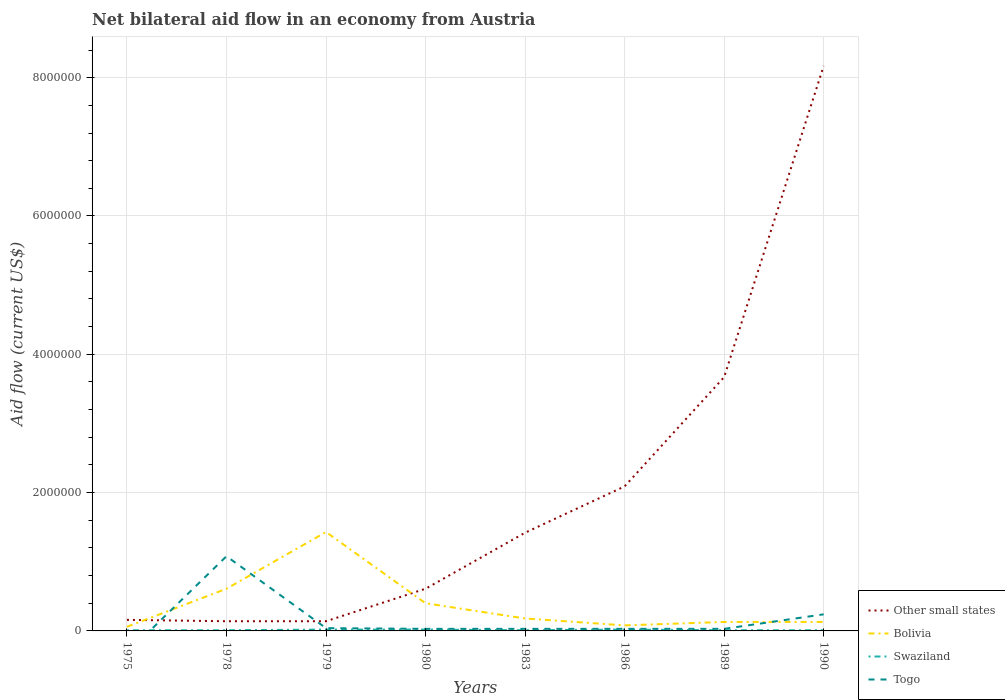How many different coloured lines are there?
Provide a short and direct response. 4. Does the line corresponding to Bolivia intersect with the line corresponding to Swaziland?
Give a very brief answer. No. Is the number of lines equal to the number of legend labels?
Keep it short and to the point. No. What is the total net bilateral aid flow in Other small states in the graph?
Make the answer very short. -8.01e+06. What is the difference between the highest and the second highest net bilateral aid flow in Other small states?
Keep it short and to the point. 8.03e+06. Is the net bilateral aid flow in Other small states strictly greater than the net bilateral aid flow in Togo over the years?
Provide a short and direct response. No. How many lines are there?
Offer a terse response. 4. How many years are there in the graph?
Your answer should be compact. 8. Are the values on the major ticks of Y-axis written in scientific E-notation?
Your answer should be very brief. No. Does the graph contain any zero values?
Make the answer very short. Yes. Does the graph contain grids?
Ensure brevity in your answer.  Yes. How many legend labels are there?
Your answer should be compact. 4. How are the legend labels stacked?
Provide a short and direct response. Vertical. What is the title of the graph?
Ensure brevity in your answer.  Net bilateral aid flow in an economy from Austria. What is the label or title of the X-axis?
Your answer should be very brief. Years. What is the Aid flow (current US$) in Bolivia in 1975?
Keep it short and to the point. 6.00e+04. What is the Aid flow (current US$) of Bolivia in 1978?
Provide a succinct answer. 6.10e+05. What is the Aid flow (current US$) of Swaziland in 1978?
Your answer should be compact. 10000. What is the Aid flow (current US$) in Togo in 1978?
Keep it short and to the point. 1.08e+06. What is the Aid flow (current US$) in Other small states in 1979?
Give a very brief answer. 1.40e+05. What is the Aid flow (current US$) in Bolivia in 1979?
Ensure brevity in your answer.  1.43e+06. What is the Aid flow (current US$) in Swaziland in 1979?
Your answer should be compact. 2.00e+04. What is the Aid flow (current US$) in Togo in 1979?
Provide a short and direct response. 4.00e+04. What is the Aid flow (current US$) in Other small states in 1980?
Make the answer very short. 6.10e+05. What is the Aid flow (current US$) of Bolivia in 1980?
Keep it short and to the point. 4.00e+05. What is the Aid flow (current US$) in Swaziland in 1980?
Your answer should be compact. 2.00e+04. What is the Aid flow (current US$) of Togo in 1980?
Offer a very short reply. 3.00e+04. What is the Aid flow (current US$) of Other small states in 1983?
Your answer should be very brief. 1.42e+06. What is the Aid flow (current US$) in Bolivia in 1983?
Offer a terse response. 1.80e+05. What is the Aid flow (current US$) in Swaziland in 1983?
Offer a terse response. 10000. What is the Aid flow (current US$) in Togo in 1983?
Your response must be concise. 3.00e+04. What is the Aid flow (current US$) in Other small states in 1986?
Give a very brief answer. 2.09e+06. What is the Aid flow (current US$) of Bolivia in 1986?
Give a very brief answer. 8.00e+04. What is the Aid flow (current US$) of Other small states in 1989?
Your answer should be very brief. 3.67e+06. What is the Aid flow (current US$) of Other small states in 1990?
Offer a very short reply. 8.17e+06. What is the Aid flow (current US$) of Togo in 1990?
Your answer should be compact. 2.40e+05. Across all years, what is the maximum Aid flow (current US$) of Other small states?
Offer a very short reply. 8.17e+06. Across all years, what is the maximum Aid flow (current US$) of Bolivia?
Offer a very short reply. 1.43e+06. Across all years, what is the maximum Aid flow (current US$) in Swaziland?
Give a very brief answer. 2.00e+04. Across all years, what is the maximum Aid flow (current US$) in Togo?
Offer a very short reply. 1.08e+06. Across all years, what is the minimum Aid flow (current US$) in Other small states?
Offer a very short reply. 1.40e+05. Across all years, what is the minimum Aid flow (current US$) of Bolivia?
Make the answer very short. 6.00e+04. Across all years, what is the minimum Aid flow (current US$) of Swaziland?
Your answer should be compact. 10000. Across all years, what is the minimum Aid flow (current US$) of Togo?
Provide a succinct answer. 0. What is the total Aid flow (current US$) of Other small states in the graph?
Ensure brevity in your answer.  1.64e+07. What is the total Aid flow (current US$) in Bolivia in the graph?
Your response must be concise. 3.02e+06. What is the total Aid flow (current US$) of Togo in the graph?
Offer a terse response. 1.48e+06. What is the difference between the Aid flow (current US$) of Bolivia in 1975 and that in 1978?
Your response must be concise. -5.50e+05. What is the difference between the Aid flow (current US$) in Bolivia in 1975 and that in 1979?
Give a very brief answer. -1.37e+06. What is the difference between the Aid flow (current US$) of Other small states in 1975 and that in 1980?
Offer a very short reply. -4.50e+05. What is the difference between the Aid flow (current US$) of Bolivia in 1975 and that in 1980?
Give a very brief answer. -3.40e+05. What is the difference between the Aid flow (current US$) of Swaziland in 1975 and that in 1980?
Your response must be concise. -10000. What is the difference between the Aid flow (current US$) of Other small states in 1975 and that in 1983?
Offer a very short reply. -1.26e+06. What is the difference between the Aid flow (current US$) of Other small states in 1975 and that in 1986?
Offer a terse response. -1.93e+06. What is the difference between the Aid flow (current US$) of Bolivia in 1975 and that in 1986?
Provide a short and direct response. -2.00e+04. What is the difference between the Aid flow (current US$) of Swaziland in 1975 and that in 1986?
Keep it short and to the point. -10000. What is the difference between the Aid flow (current US$) of Other small states in 1975 and that in 1989?
Make the answer very short. -3.51e+06. What is the difference between the Aid flow (current US$) of Bolivia in 1975 and that in 1989?
Your answer should be compact. -7.00e+04. What is the difference between the Aid flow (current US$) of Swaziland in 1975 and that in 1989?
Give a very brief answer. 0. What is the difference between the Aid flow (current US$) of Other small states in 1975 and that in 1990?
Make the answer very short. -8.01e+06. What is the difference between the Aid flow (current US$) in Bolivia in 1975 and that in 1990?
Provide a short and direct response. -7.00e+04. What is the difference between the Aid flow (current US$) in Other small states in 1978 and that in 1979?
Your answer should be compact. 0. What is the difference between the Aid flow (current US$) in Bolivia in 1978 and that in 1979?
Your answer should be very brief. -8.20e+05. What is the difference between the Aid flow (current US$) of Togo in 1978 and that in 1979?
Offer a very short reply. 1.04e+06. What is the difference between the Aid flow (current US$) in Other small states in 1978 and that in 1980?
Provide a succinct answer. -4.70e+05. What is the difference between the Aid flow (current US$) in Togo in 1978 and that in 1980?
Offer a terse response. 1.05e+06. What is the difference between the Aid flow (current US$) of Other small states in 1978 and that in 1983?
Provide a succinct answer. -1.28e+06. What is the difference between the Aid flow (current US$) of Togo in 1978 and that in 1983?
Keep it short and to the point. 1.05e+06. What is the difference between the Aid flow (current US$) of Other small states in 1978 and that in 1986?
Your answer should be compact. -1.95e+06. What is the difference between the Aid flow (current US$) in Bolivia in 1978 and that in 1986?
Provide a succinct answer. 5.30e+05. What is the difference between the Aid flow (current US$) of Swaziland in 1978 and that in 1986?
Offer a terse response. -10000. What is the difference between the Aid flow (current US$) of Togo in 1978 and that in 1986?
Give a very brief answer. 1.05e+06. What is the difference between the Aid flow (current US$) of Other small states in 1978 and that in 1989?
Give a very brief answer. -3.53e+06. What is the difference between the Aid flow (current US$) in Bolivia in 1978 and that in 1989?
Provide a short and direct response. 4.80e+05. What is the difference between the Aid flow (current US$) in Togo in 1978 and that in 1989?
Give a very brief answer. 1.05e+06. What is the difference between the Aid flow (current US$) of Other small states in 1978 and that in 1990?
Offer a terse response. -8.03e+06. What is the difference between the Aid flow (current US$) of Togo in 1978 and that in 1990?
Offer a very short reply. 8.40e+05. What is the difference between the Aid flow (current US$) of Other small states in 1979 and that in 1980?
Ensure brevity in your answer.  -4.70e+05. What is the difference between the Aid flow (current US$) in Bolivia in 1979 and that in 1980?
Your answer should be very brief. 1.03e+06. What is the difference between the Aid flow (current US$) of Swaziland in 1979 and that in 1980?
Give a very brief answer. 0. What is the difference between the Aid flow (current US$) of Togo in 1979 and that in 1980?
Ensure brevity in your answer.  10000. What is the difference between the Aid flow (current US$) in Other small states in 1979 and that in 1983?
Your response must be concise. -1.28e+06. What is the difference between the Aid flow (current US$) of Bolivia in 1979 and that in 1983?
Give a very brief answer. 1.25e+06. What is the difference between the Aid flow (current US$) of Togo in 1979 and that in 1983?
Your answer should be compact. 10000. What is the difference between the Aid flow (current US$) in Other small states in 1979 and that in 1986?
Offer a very short reply. -1.95e+06. What is the difference between the Aid flow (current US$) in Bolivia in 1979 and that in 1986?
Provide a succinct answer. 1.35e+06. What is the difference between the Aid flow (current US$) in Other small states in 1979 and that in 1989?
Your answer should be very brief. -3.53e+06. What is the difference between the Aid flow (current US$) in Bolivia in 1979 and that in 1989?
Make the answer very short. 1.30e+06. What is the difference between the Aid flow (current US$) of Swaziland in 1979 and that in 1989?
Ensure brevity in your answer.  10000. What is the difference between the Aid flow (current US$) in Togo in 1979 and that in 1989?
Make the answer very short. 10000. What is the difference between the Aid flow (current US$) of Other small states in 1979 and that in 1990?
Give a very brief answer. -8.03e+06. What is the difference between the Aid flow (current US$) of Bolivia in 1979 and that in 1990?
Give a very brief answer. 1.30e+06. What is the difference between the Aid flow (current US$) in Other small states in 1980 and that in 1983?
Your answer should be compact. -8.10e+05. What is the difference between the Aid flow (current US$) of Togo in 1980 and that in 1983?
Ensure brevity in your answer.  0. What is the difference between the Aid flow (current US$) in Other small states in 1980 and that in 1986?
Provide a succinct answer. -1.48e+06. What is the difference between the Aid flow (current US$) in Bolivia in 1980 and that in 1986?
Provide a short and direct response. 3.20e+05. What is the difference between the Aid flow (current US$) in Togo in 1980 and that in 1986?
Make the answer very short. 0. What is the difference between the Aid flow (current US$) of Other small states in 1980 and that in 1989?
Make the answer very short. -3.06e+06. What is the difference between the Aid flow (current US$) in Bolivia in 1980 and that in 1989?
Provide a short and direct response. 2.70e+05. What is the difference between the Aid flow (current US$) of Togo in 1980 and that in 1989?
Keep it short and to the point. 0. What is the difference between the Aid flow (current US$) in Other small states in 1980 and that in 1990?
Provide a succinct answer. -7.56e+06. What is the difference between the Aid flow (current US$) of Bolivia in 1980 and that in 1990?
Offer a very short reply. 2.70e+05. What is the difference between the Aid flow (current US$) of Swaziland in 1980 and that in 1990?
Keep it short and to the point. 10000. What is the difference between the Aid flow (current US$) in Togo in 1980 and that in 1990?
Offer a terse response. -2.10e+05. What is the difference between the Aid flow (current US$) of Other small states in 1983 and that in 1986?
Give a very brief answer. -6.70e+05. What is the difference between the Aid flow (current US$) of Bolivia in 1983 and that in 1986?
Provide a succinct answer. 1.00e+05. What is the difference between the Aid flow (current US$) of Swaziland in 1983 and that in 1986?
Offer a terse response. -10000. What is the difference between the Aid flow (current US$) of Togo in 1983 and that in 1986?
Your answer should be compact. 0. What is the difference between the Aid flow (current US$) of Other small states in 1983 and that in 1989?
Ensure brevity in your answer.  -2.25e+06. What is the difference between the Aid flow (current US$) in Bolivia in 1983 and that in 1989?
Ensure brevity in your answer.  5.00e+04. What is the difference between the Aid flow (current US$) of Swaziland in 1983 and that in 1989?
Offer a terse response. 0. What is the difference between the Aid flow (current US$) in Other small states in 1983 and that in 1990?
Keep it short and to the point. -6.75e+06. What is the difference between the Aid flow (current US$) in Bolivia in 1983 and that in 1990?
Provide a short and direct response. 5.00e+04. What is the difference between the Aid flow (current US$) of Swaziland in 1983 and that in 1990?
Provide a succinct answer. 0. What is the difference between the Aid flow (current US$) in Togo in 1983 and that in 1990?
Make the answer very short. -2.10e+05. What is the difference between the Aid flow (current US$) in Other small states in 1986 and that in 1989?
Provide a succinct answer. -1.58e+06. What is the difference between the Aid flow (current US$) of Other small states in 1986 and that in 1990?
Provide a succinct answer. -6.08e+06. What is the difference between the Aid flow (current US$) of Other small states in 1989 and that in 1990?
Offer a terse response. -4.50e+06. What is the difference between the Aid flow (current US$) in Bolivia in 1989 and that in 1990?
Provide a succinct answer. 0. What is the difference between the Aid flow (current US$) of Other small states in 1975 and the Aid flow (current US$) of Bolivia in 1978?
Keep it short and to the point. -4.50e+05. What is the difference between the Aid flow (current US$) of Other small states in 1975 and the Aid flow (current US$) of Swaziland in 1978?
Your answer should be compact. 1.50e+05. What is the difference between the Aid flow (current US$) of Other small states in 1975 and the Aid flow (current US$) of Togo in 1978?
Your answer should be very brief. -9.20e+05. What is the difference between the Aid flow (current US$) in Bolivia in 1975 and the Aid flow (current US$) in Togo in 1978?
Your response must be concise. -1.02e+06. What is the difference between the Aid flow (current US$) of Swaziland in 1975 and the Aid flow (current US$) of Togo in 1978?
Offer a terse response. -1.07e+06. What is the difference between the Aid flow (current US$) in Other small states in 1975 and the Aid flow (current US$) in Bolivia in 1979?
Provide a short and direct response. -1.27e+06. What is the difference between the Aid flow (current US$) of Bolivia in 1975 and the Aid flow (current US$) of Swaziland in 1979?
Give a very brief answer. 4.00e+04. What is the difference between the Aid flow (current US$) of Other small states in 1975 and the Aid flow (current US$) of Swaziland in 1980?
Make the answer very short. 1.40e+05. What is the difference between the Aid flow (current US$) of Other small states in 1975 and the Aid flow (current US$) of Togo in 1980?
Your answer should be very brief. 1.30e+05. What is the difference between the Aid flow (current US$) in Bolivia in 1975 and the Aid flow (current US$) in Swaziland in 1980?
Offer a terse response. 4.00e+04. What is the difference between the Aid flow (current US$) of Other small states in 1975 and the Aid flow (current US$) of Swaziland in 1983?
Provide a succinct answer. 1.50e+05. What is the difference between the Aid flow (current US$) in Other small states in 1975 and the Aid flow (current US$) in Togo in 1983?
Offer a very short reply. 1.30e+05. What is the difference between the Aid flow (current US$) in Bolivia in 1975 and the Aid flow (current US$) in Swaziland in 1983?
Ensure brevity in your answer.  5.00e+04. What is the difference between the Aid flow (current US$) in Bolivia in 1975 and the Aid flow (current US$) in Togo in 1983?
Give a very brief answer. 3.00e+04. What is the difference between the Aid flow (current US$) in Other small states in 1975 and the Aid flow (current US$) in Bolivia in 1986?
Offer a terse response. 8.00e+04. What is the difference between the Aid flow (current US$) in Bolivia in 1975 and the Aid flow (current US$) in Swaziland in 1986?
Give a very brief answer. 4.00e+04. What is the difference between the Aid flow (current US$) in Swaziland in 1975 and the Aid flow (current US$) in Togo in 1986?
Offer a very short reply. -2.00e+04. What is the difference between the Aid flow (current US$) of Other small states in 1975 and the Aid flow (current US$) of Swaziland in 1989?
Provide a succinct answer. 1.50e+05. What is the difference between the Aid flow (current US$) of Other small states in 1975 and the Aid flow (current US$) of Togo in 1989?
Provide a succinct answer. 1.30e+05. What is the difference between the Aid flow (current US$) of Bolivia in 1975 and the Aid flow (current US$) of Swaziland in 1989?
Provide a succinct answer. 5.00e+04. What is the difference between the Aid flow (current US$) in Bolivia in 1975 and the Aid flow (current US$) in Togo in 1989?
Your answer should be very brief. 3.00e+04. What is the difference between the Aid flow (current US$) in Other small states in 1975 and the Aid flow (current US$) in Togo in 1990?
Provide a succinct answer. -8.00e+04. What is the difference between the Aid flow (current US$) of Bolivia in 1975 and the Aid flow (current US$) of Swaziland in 1990?
Provide a short and direct response. 5.00e+04. What is the difference between the Aid flow (current US$) in Bolivia in 1975 and the Aid flow (current US$) in Togo in 1990?
Provide a short and direct response. -1.80e+05. What is the difference between the Aid flow (current US$) of Other small states in 1978 and the Aid flow (current US$) of Bolivia in 1979?
Keep it short and to the point. -1.29e+06. What is the difference between the Aid flow (current US$) in Other small states in 1978 and the Aid flow (current US$) in Swaziland in 1979?
Your answer should be compact. 1.20e+05. What is the difference between the Aid flow (current US$) of Bolivia in 1978 and the Aid flow (current US$) of Swaziland in 1979?
Your answer should be compact. 5.90e+05. What is the difference between the Aid flow (current US$) of Bolivia in 1978 and the Aid flow (current US$) of Togo in 1979?
Offer a very short reply. 5.70e+05. What is the difference between the Aid flow (current US$) of Swaziland in 1978 and the Aid flow (current US$) of Togo in 1979?
Give a very brief answer. -3.00e+04. What is the difference between the Aid flow (current US$) in Other small states in 1978 and the Aid flow (current US$) in Bolivia in 1980?
Offer a very short reply. -2.60e+05. What is the difference between the Aid flow (current US$) of Other small states in 1978 and the Aid flow (current US$) of Swaziland in 1980?
Give a very brief answer. 1.20e+05. What is the difference between the Aid flow (current US$) in Other small states in 1978 and the Aid flow (current US$) in Togo in 1980?
Provide a succinct answer. 1.10e+05. What is the difference between the Aid flow (current US$) in Bolivia in 1978 and the Aid flow (current US$) in Swaziland in 1980?
Your answer should be very brief. 5.90e+05. What is the difference between the Aid flow (current US$) in Bolivia in 1978 and the Aid flow (current US$) in Togo in 1980?
Ensure brevity in your answer.  5.80e+05. What is the difference between the Aid flow (current US$) of Swaziland in 1978 and the Aid flow (current US$) of Togo in 1980?
Offer a terse response. -2.00e+04. What is the difference between the Aid flow (current US$) in Other small states in 1978 and the Aid flow (current US$) in Swaziland in 1983?
Your answer should be compact. 1.30e+05. What is the difference between the Aid flow (current US$) of Bolivia in 1978 and the Aid flow (current US$) of Swaziland in 1983?
Make the answer very short. 6.00e+05. What is the difference between the Aid flow (current US$) of Bolivia in 1978 and the Aid flow (current US$) of Togo in 1983?
Give a very brief answer. 5.80e+05. What is the difference between the Aid flow (current US$) of Swaziland in 1978 and the Aid flow (current US$) of Togo in 1983?
Your response must be concise. -2.00e+04. What is the difference between the Aid flow (current US$) in Bolivia in 1978 and the Aid flow (current US$) in Swaziland in 1986?
Offer a very short reply. 5.90e+05. What is the difference between the Aid flow (current US$) of Bolivia in 1978 and the Aid flow (current US$) of Togo in 1986?
Give a very brief answer. 5.80e+05. What is the difference between the Aid flow (current US$) of Swaziland in 1978 and the Aid flow (current US$) of Togo in 1986?
Provide a short and direct response. -2.00e+04. What is the difference between the Aid flow (current US$) in Other small states in 1978 and the Aid flow (current US$) in Togo in 1989?
Your answer should be compact. 1.10e+05. What is the difference between the Aid flow (current US$) in Bolivia in 1978 and the Aid flow (current US$) in Swaziland in 1989?
Offer a terse response. 6.00e+05. What is the difference between the Aid flow (current US$) in Bolivia in 1978 and the Aid flow (current US$) in Togo in 1989?
Offer a very short reply. 5.80e+05. What is the difference between the Aid flow (current US$) in Swaziland in 1978 and the Aid flow (current US$) in Togo in 1989?
Give a very brief answer. -2.00e+04. What is the difference between the Aid flow (current US$) of Other small states in 1978 and the Aid flow (current US$) of Bolivia in 1990?
Offer a very short reply. 10000. What is the difference between the Aid flow (current US$) in Other small states in 1979 and the Aid flow (current US$) in Bolivia in 1980?
Your answer should be compact. -2.60e+05. What is the difference between the Aid flow (current US$) of Other small states in 1979 and the Aid flow (current US$) of Swaziland in 1980?
Your answer should be very brief. 1.20e+05. What is the difference between the Aid flow (current US$) of Other small states in 1979 and the Aid flow (current US$) of Togo in 1980?
Offer a very short reply. 1.10e+05. What is the difference between the Aid flow (current US$) of Bolivia in 1979 and the Aid flow (current US$) of Swaziland in 1980?
Provide a succinct answer. 1.41e+06. What is the difference between the Aid flow (current US$) in Bolivia in 1979 and the Aid flow (current US$) in Togo in 1980?
Give a very brief answer. 1.40e+06. What is the difference between the Aid flow (current US$) of Other small states in 1979 and the Aid flow (current US$) of Bolivia in 1983?
Provide a succinct answer. -4.00e+04. What is the difference between the Aid flow (current US$) of Bolivia in 1979 and the Aid flow (current US$) of Swaziland in 1983?
Offer a very short reply. 1.42e+06. What is the difference between the Aid flow (current US$) of Bolivia in 1979 and the Aid flow (current US$) of Togo in 1983?
Offer a very short reply. 1.40e+06. What is the difference between the Aid flow (current US$) in Swaziland in 1979 and the Aid flow (current US$) in Togo in 1983?
Provide a succinct answer. -10000. What is the difference between the Aid flow (current US$) of Other small states in 1979 and the Aid flow (current US$) of Swaziland in 1986?
Offer a very short reply. 1.20e+05. What is the difference between the Aid flow (current US$) in Bolivia in 1979 and the Aid flow (current US$) in Swaziland in 1986?
Offer a very short reply. 1.41e+06. What is the difference between the Aid flow (current US$) in Bolivia in 1979 and the Aid flow (current US$) in Togo in 1986?
Ensure brevity in your answer.  1.40e+06. What is the difference between the Aid flow (current US$) of Swaziland in 1979 and the Aid flow (current US$) of Togo in 1986?
Keep it short and to the point. -10000. What is the difference between the Aid flow (current US$) in Other small states in 1979 and the Aid flow (current US$) in Bolivia in 1989?
Make the answer very short. 10000. What is the difference between the Aid flow (current US$) of Other small states in 1979 and the Aid flow (current US$) of Swaziland in 1989?
Your response must be concise. 1.30e+05. What is the difference between the Aid flow (current US$) of Other small states in 1979 and the Aid flow (current US$) of Togo in 1989?
Make the answer very short. 1.10e+05. What is the difference between the Aid flow (current US$) in Bolivia in 1979 and the Aid flow (current US$) in Swaziland in 1989?
Offer a terse response. 1.42e+06. What is the difference between the Aid flow (current US$) in Bolivia in 1979 and the Aid flow (current US$) in Togo in 1989?
Keep it short and to the point. 1.40e+06. What is the difference between the Aid flow (current US$) in Other small states in 1979 and the Aid flow (current US$) in Togo in 1990?
Your response must be concise. -1.00e+05. What is the difference between the Aid flow (current US$) in Bolivia in 1979 and the Aid flow (current US$) in Swaziland in 1990?
Ensure brevity in your answer.  1.42e+06. What is the difference between the Aid flow (current US$) in Bolivia in 1979 and the Aid flow (current US$) in Togo in 1990?
Provide a short and direct response. 1.19e+06. What is the difference between the Aid flow (current US$) in Other small states in 1980 and the Aid flow (current US$) in Togo in 1983?
Make the answer very short. 5.80e+05. What is the difference between the Aid flow (current US$) of Bolivia in 1980 and the Aid flow (current US$) of Swaziland in 1983?
Provide a succinct answer. 3.90e+05. What is the difference between the Aid flow (current US$) in Bolivia in 1980 and the Aid flow (current US$) in Togo in 1983?
Provide a succinct answer. 3.70e+05. What is the difference between the Aid flow (current US$) of Other small states in 1980 and the Aid flow (current US$) of Bolivia in 1986?
Provide a short and direct response. 5.30e+05. What is the difference between the Aid flow (current US$) in Other small states in 1980 and the Aid flow (current US$) in Swaziland in 1986?
Ensure brevity in your answer.  5.90e+05. What is the difference between the Aid flow (current US$) in Other small states in 1980 and the Aid flow (current US$) in Togo in 1986?
Ensure brevity in your answer.  5.80e+05. What is the difference between the Aid flow (current US$) of Bolivia in 1980 and the Aid flow (current US$) of Swaziland in 1986?
Your answer should be very brief. 3.80e+05. What is the difference between the Aid flow (current US$) of Bolivia in 1980 and the Aid flow (current US$) of Togo in 1986?
Offer a terse response. 3.70e+05. What is the difference between the Aid flow (current US$) of Other small states in 1980 and the Aid flow (current US$) of Bolivia in 1989?
Offer a very short reply. 4.80e+05. What is the difference between the Aid flow (current US$) in Other small states in 1980 and the Aid flow (current US$) in Togo in 1989?
Keep it short and to the point. 5.80e+05. What is the difference between the Aid flow (current US$) of Bolivia in 1980 and the Aid flow (current US$) of Swaziland in 1989?
Keep it short and to the point. 3.90e+05. What is the difference between the Aid flow (current US$) in Other small states in 1980 and the Aid flow (current US$) in Bolivia in 1990?
Offer a very short reply. 4.80e+05. What is the difference between the Aid flow (current US$) in Other small states in 1980 and the Aid flow (current US$) in Swaziland in 1990?
Your answer should be compact. 6.00e+05. What is the difference between the Aid flow (current US$) in Other small states in 1980 and the Aid flow (current US$) in Togo in 1990?
Your answer should be compact. 3.70e+05. What is the difference between the Aid flow (current US$) of Bolivia in 1980 and the Aid flow (current US$) of Swaziland in 1990?
Provide a succinct answer. 3.90e+05. What is the difference between the Aid flow (current US$) in Swaziland in 1980 and the Aid flow (current US$) in Togo in 1990?
Keep it short and to the point. -2.20e+05. What is the difference between the Aid flow (current US$) in Other small states in 1983 and the Aid flow (current US$) in Bolivia in 1986?
Ensure brevity in your answer.  1.34e+06. What is the difference between the Aid flow (current US$) in Other small states in 1983 and the Aid flow (current US$) in Swaziland in 1986?
Your answer should be compact. 1.40e+06. What is the difference between the Aid flow (current US$) in Other small states in 1983 and the Aid flow (current US$) in Togo in 1986?
Provide a succinct answer. 1.39e+06. What is the difference between the Aid flow (current US$) in Bolivia in 1983 and the Aid flow (current US$) in Swaziland in 1986?
Ensure brevity in your answer.  1.60e+05. What is the difference between the Aid flow (current US$) of Bolivia in 1983 and the Aid flow (current US$) of Togo in 1986?
Offer a terse response. 1.50e+05. What is the difference between the Aid flow (current US$) of Swaziland in 1983 and the Aid flow (current US$) of Togo in 1986?
Keep it short and to the point. -2.00e+04. What is the difference between the Aid flow (current US$) of Other small states in 1983 and the Aid flow (current US$) of Bolivia in 1989?
Provide a short and direct response. 1.29e+06. What is the difference between the Aid flow (current US$) of Other small states in 1983 and the Aid flow (current US$) of Swaziland in 1989?
Your answer should be very brief. 1.41e+06. What is the difference between the Aid flow (current US$) of Other small states in 1983 and the Aid flow (current US$) of Togo in 1989?
Keep it short and to the point. 1.39e+06. What is the difference between the Aid flow (current US$) in Bolivia in 1983 and the Aid flow (current US$) in Swaziland in 1989?
Your answer should be very brief. 1.70e+05. What is the difference between the Aid flow (current US$) of Bolivia in 1983 and the Aid flow (current US$) of Togo in 1989?
Offer a terse response. 1.50e+05. What is the difference between the Aid flow (current US$) of Swaziland in 1983 and the Aid flow (current US$) of Togo in 1989?
Make the answer very short. -2.00e+04. What is the difference between the Aid flow (current US$) of Other small states in 1983 and the Aid flow (current US$) of Bolivia in 1990?
Ensure brevity in your answer.  1.29e+06. What is the difference between the Aid flow (current US$) in Other small states in 1983 and the Aid flow (current US$) in Swaziland in 1990?
Give a very brief answer. 1.41e+06. What is the difference between the Aid flow (current US$) in Other small states in 1983 and the Aid flow (current US$) in Togo in 1990?
Give a very brief answer. 1.18e+06. What is the difference between the Aid flow (current US$) in Bolivia in 1983 and the Aid flow (current US$) in Togo in 1990?
Provide a succinct answer. -6.00e+04. What is the difference between the Aid flow (current US$) in Other small states in 1986 and the Aid flow (current US$) in Bolivia in 1989?
Offer a terse response. 1.96e+06. What is the difference between the Aid flow (current US$) of Other small states in 1986 and the Aid flow (current US$) of Swaziland in 1989?
Your response must be concise. 2.08e+06. What is the difference between the Aid flow (current US$) of Other small states in 1986 and the Aid flow (current US$) of Togo in 1989?
Your answer should be compact. 2.06e+06. What is the difference between the Aid flow (current US$) of Bolivia in 1986 and the Aid flow (current US$) of Swaziland in 1989?
Your answer should be compact. 7.00e+04. What is the difference between the Aid flow (current US$) of Bolivia in 1986 and the Aid flow (current US$) of Togo in 1989?
Offer a very short reply. 5.00e+04. What is the difference between the Aid flow (current US$) of Swaziland in 1986 and the Aid flow (current US$) of Togo in 1989?
Make the answer very short. -10000. What is the difference between the Aid flow (current US$) in Other small states in 1986 and the Aid flow (current US$) in Bolivia in 1990?
Your response must be concise. 1.96e+06. What is the difference between the Aid flow (current US$) in Other small states in 1986 and the Aid flow (current US$) in Swaziland in 1990?
Your response must be concise. 2.08e+06. What is the difference between the Aid flow (current US$) in Other small states in 1986 and the Aid flow (current US$) in Togo in 1990?
Your answer should be compact. 1.85e+06. What is the difference between the Aid flow (current US$) in Bolivia in 1986 and the Aid flow (current US$) in Togo in 1990?
Your answer should be compact. -1.60e+05. What is the difference between the Aid flow (current US$) in Swaziland in 1986 and the Aid flow (current US$) in Togo in 1990?
Offer a terse response. -2.20e+05. What is the difference between the Aid flow (current US$) of Other small states in 1989 and the Aid flow (current US$) of Bolivia in 1990?
Keep it short and to the point. 3.54e+06. What is the difference between the Aid flow (current US$) in Other small states in 1989 and the Aid flow (current US$) in Swaziland in 1990?
Provide a succinct answer. 3.66e+06. What is the difference between the Aid flow (current US$) of Other small states in 1989 and the Aid flow (current US$) of Togo in 1990?
Your answer should be very brief. 3.43e+06. What is the difference between the Aid flow (current US$) in Bolivia in 1989 and the Aid flow (current US$) in Swaziland in 1990?
Provide a succinct answer. 1.20e+05. What is the average Aid flow (current US$) in Other small states per year?
Ensure brevity in your answer.  2.05e+06. What is the average Aid flow (current US$) in Bolivia per year?
Your answer should be compact. 3.78e+05. What is the average Aid flow (current US$) in Swaziland per year?
Make the answer very short. 1.38e+04. What is the average Aid flow (current US$) of Togo per year?
Your response must be concise. 1.85e+05. In the year 1975, what is the difference between the Aid flow (current US$) in Other small states and Aid flow (current US$) in Bolivia?
Provide a succinct answer. 1.00e+05. In the year 1975, what is the difference between the Aid flow (current US$) of Other small states and Aid flow (current US$) of Swaziland?
Make the answer very short. 1.50e+05. In the year 1978, what is the difference between the Aid flow (current US$) of Other small states and Aid flow (current US$) of Bolivia?
Provide a short and direct response. -4.70e+05. In the year 1978, what is the difference between the Aid flow (current US$) of Other small states and Aid flow (current US$) of Togo?
Offer a very short reply. -9.40e+05. In the year 1978, what is the difference between the Aid flow (current US$) of Bolivia and Aid flow (current US$) of Togo?
Your response must be concise. -4.70e+05. In the year 1978, what is the difference between the Aid flow (current US$) of Swaziland and Aid flow (current US$) of Togo?
Your response must be concise. -1.07e+06. In the year 1979, what is the difference between the Aid flow (current US$) in Other small states and Aid flow (current US$) in Bolivia?
Ensure brevity in your answer.  -1.29e+06. In the year 1979, what is the difference between the Aid flow (current US$) in Other small states and Aid flow (current US$) in Swaziland?
Your response must be concise. 1.20e+05. In the year 1979, what is the difference between the Aid flow (current US$) of Bolivia and Aid flow (current US$) of Swaziland?
Offer a very short reply. 1.41e+06. In the year 1979, what is the difference between the Aid flow (current US$) of Bolivia and Aid flow (current US$) of Togo?
Make the answer very short. 1.39e+06. In the year 1980, what is the difference between the Aid flow (current US$) in Other small states and Aid flow (current US$) in Swaziland?
Keep it short and to the point. 5.90e+05. In the year 1980, what is the difference between the Aid flow (current US$) of Other small states and Aid flow (current US$) of Togo?
Your answer should be compact. 5.80e+05. In the year 1980, what is the difference between the Aid flow (current US$) in Bolivia and Aid flow (current US$) in Togo?
Ensure brevity in your answer.  3.70e+05. In the year 1983, what is the difference between the Aid flow (current US$) in Other small states and Aid flow (current US$) in Bolivia?
Ensure brevity in your answer.  1.24e+06. In the year 1983, what is the difference between the Aid flow (current US$) in Other small states and Aid flow (current US$) in Swaziland?
Provide a short and direct response. 1.41e+06. In the year 1983, what is the difference between the Aid flow (current US$) of Other small states and Aid flow (current US$) of Togo?
Ensure brevity in your answer.  1.39e+06. In the year 1983, what is the difference between the Aid flow (current US$) in Bolivia and Aid flow (current US$) in Swaziland?
Make the answer very short. 1.70e+05. In the year 1983, what is the difference between the Aid flow (current US$) in Bolivia and Aid flow (current US$) in Togo?
Offer a terse response. 1.50e+05. In the year 1983, what is the difference between the Aid flow (current US$) in Swaziland and Aid flow (current US$) in Togo?
Your response must be concise. -2.00e+04. In the year 1986, what is the difference between the Aid flow (current US$) of Other small states and Aid flow (current US$) of Bolivia?
Your response must be concise. 2.01e+06. In the year 1986, what is the difference between the Aid flow (current US$) of Other small states and Aid flow (current US$) of Swaziland?
Give a very brief answer. 2.07e+06. In the year 1986, what is the difference between the Aid flow (current US$) of Other small states and Aid flow (current US$) of Togo?
Offer a terse response. 2.06e+06. In the year 1986, what is the difference between the Aid flow (current US$) in Swaziland and Aid flow (current US$) in Togo?
Give a very brief answer. -10000. In the year 1989, what is the difference between the Aid flow (current US$) of Other small states and Aid flow (current US$) of Bolivia?
Provide a short and direct response. 3.54e+06. In the year 1989, what is the difference between the Aid flow (current US$) of Other small states and Aid flow (current US$) of Swaziland?
Keep it short and to the point. 3.66e+06. In the year 1989, what is the difference between the Aid flow (current US$) of Other small states and Aid flow (current US$) of Togo?
Give a very brief answer. 3.64e+06. In the year 1989, what is the difference between the Aid flow (current US$) of Bolivia and Aid flow (current US$) of Swaziland?
Provide a succinct answer. 1.20e+05. In the year 1989, what is the difference between the Aid flow (current US$) in Swaziland and Aid flow (current US$) in Togo?
Give a very brief answer. -2.00e+04. In the year 1990, what is the difference between the Aid flow (current US$) of Other small states and Aid flow (current US$) of Bolivia?
Offer a very short reply. 8.04e+06. In the year 1990, what is the difference between the Aid flow (current US$) in Other small states and Aid flow (current US$) in Swaziland?
Your response must be concise. 8.16e+06. In the year 1990, what is the difference between the Aid flow (current US$) in Other small states and Aid flow (current US$) in Togo?
Your answer should be very brief. 7.93e+06. In the year 1990, what is the difference between the Aid flow (current US$) of Bolivia and Aid flow (current US$) of Swaziland?
Offer a terse response. 1.20e+05. In the year 1990, what is the difference between the Aid flow (current US$) in Bolivia and Aid flow (current US$) in Togo?
Give a very brief answer. -1.10e+05. In the year 1990, what is the difference between the Aid flow (current US$) in Swaziland and Aid flow (current US$) in Togo?
Offer a very short reply. -2.30e+05. What is the ratio of the Aid flow (current US$) in Bolivia in 1975 to that in 1978?
Provide a succinct answer. 0.1. What is the ratio of the Aid flow (current US$) of Swaziland in 1975 to that in 1978?
Offer a terse response. 1. What is the ratio of the Aid flow (current US$) of Other small states in 1975 to that in 1979?
Your answer should be compact. 1.14. What is the ratio of the Aid flow (current US$) in Bolivia in 1975 to that in 1979?
Keep it short and to the point. 0.04. What is the ratio of the Aid flow (current US$) in Other small states in 1975 to that in 1980?
Offer a terse response. 0.26. What is the ratio of the Aid flow (current US$) of Other small states in 1975 to that in 1983?
Make the answer very short. 0.11. What is the ratio of the Aid flow (current US$) in Other small states in 1975 to that in 1986?
Offer a terse response. 0.08. What is the ratio of the Aid flow (current US$) in Other small states in 1975 to that in 1989?
Give a very brief answer. 0.04. What is the ratio of the Aid flow (current US$) in Bolivia in 1975 to that in 1989?
Make the answer very short. 0.46. What is the ratio of the Aid flow (current US$) in Other small states in 1975 to that in 1990?
Ensure brevity in your answer.  0.02. What is the ratio of the Aid flow (current US$) in Bolivia in 1975 to that in 1990?
Your response must be concise. 0.46. What is the ratio of the Aid flow (current US$) in Swaziland in 1975 to that in 1990?
Ensure brevity in your answer.  1. What is the ratio of the Aid flow (current US$) of Bolivia in 1978 to that in 1979?
Provide a short and direct response. 0.43. What is the ratio of the Aid flow (current US$) in Swaziland in 1978 to that in 1979?
Give a very brief answer. 0.5. What is the ratio of the Aid flow (current US$) of Other small states in 1978 to that in 1980?
Provide a succinct answer. 0.23. What is the ratio of the Aid flow (current US$) of Bolivia in 1978 to that in 1980?
Your response must be concise. 1.52. What is the ratio of the Aid flow (current US$) of Swaziland in 1978 to that in 1980?
Your answer should be compact. 0.5. What is the ratio of the Aid flow (current US$) of Togo in 1978 to that in 1980?
Make the answer very short. 36. What is the ratio of the Aid flow (current US$) in Other small states in 1978 to that in 1983?
Offer a very short reply. 0.1. What is the ratio of the Aid flow (current US$) in Bolivia in 1978 to that in 1983?
Keep it short and to the point. 3.39. What is the ratio of the Aid flow (current US$) in Other small states in 1978 to that in 1986?
Provide a succinct answer. 0.07. What is the ratio of the Aid flow (current US$) of Bolivia in 1978 to that in 1986?
Give a very brief answer. 7.62. What is the ratio of the Aid flow (current US$) in Togo in 1978 to that in 1986?
Keep it short and to the point. 36. What is the ratio of the Aid flow (current US$) of Other small states in 1978 to that in 1989?
Your answer should be very brief. 0.04. What is the ratio of the Aid flow (current US$) in Bolivia in 1978 to that in 1989?
Make the answer very short. 4.69. What is the ratio of the Aid flow (current US$) of Togo in 1978 to that in 1989?
Make the answer very short. 36. What is the ratio of the Aid flow (current US$) in Other small states in 1978 to that in 1990?
Provide a short and direct response. 0.02. What is the ratio of the Aid flow (current US$) of Bolivia in 1978 to that in 1990?
Make the answer very short. 4.69. What is the ratio of the Aid flow (current US$) in Swaziland in 1978 to that in 1990?
Your response must be concise. 1. What is the ratio of the Aid flow (current US$) in Other small states in 1979 to that in 1980?
Provide a short and direct response. 0.23. What is the ratio of the Aid flow (current US$) in Bolivia in 1979 to that in 1980?
Offer a very short reply. 3.58. What is the ratio of the Aid flow (current US$) in Swaziland in 1979 to that in 1980?
Offer a terse response. 1. What is the ratio of the Aid flow (current US$) of Other small states in 1979 to that in 1983?
Your answer should be compact. 0.1. What is the ratio of the Aid flow (current US$) of Bolivia in 1979 to that in 1983?
Ensure brevity in your answer.  7.94. What is the ratio of the Aid flow (current US$) of Swaziland in 1979 to that in 1983?
Your response must be concise. 2. What is the ratio of the Aid flow (current US$) in Other small states in 1979 to that in 1986?
Your response must be concise. 0.07. What is the ratio of the Aid flow (current US$) of Bolivia in 1979 to that in 1986?
Your answer should be compact. 17.88. What is the ratio of the Aid flow (current US$) of Swaziland in 1979 to that in 1986?
Your response must be concise. 1. What is the ratio of the Aid flow (current US$) in Togo in 1979 to that in 1986?
Provide a succinct answer. 1.33. What is the ratio of the Aid flow (current US$) of Other small states in 1979 to that in 1989?
Provide a succinct answer. 0.04. What is the ratio of the Aid flow (current US$) in Togo in 1979 to that in 1989?
Offer a very short reply. 1.33. What is the ratio of the Aid flow (current US$) of Other small states in 1979 to that in 1990?
Your answer should be compact. 0.02. What is the ratio of the Aid flow (current US$) of Bolivia in 1979 to that in 1990?
Provide a succinct answer. 11. What is the ratio of the Aid flow (current US$) of Togo in 1979 to that in 1990?
Ensure brevity in your answer.  0.17. What is the ratio of the Aid flow (current US$) in Other small states in 1980 to that in 1983?
Provide a succinct answer. 0.43. What is the ratio of the Aid flow (current US$) of Bolivia in 1980 to that in 1983?
Your response must be concise. 2.22. What is the ratio of the Aid flow (current US$) of Swaziland in 1980 to that in 1983?
Your response must be concise. 2. What is the ratio of the Aid flow (current US$) of Other small states in 1980 to that in 1986?
Your response must be concise. 0.29. What is the ratio of the Aid flow (current US$) of Bolivia in 1980 to that in 1986?
Ensure brevity in your answer.  5. What is the ratio of the Aid flow (current US$) of Swaziland in 1980 to that in 1986?
Provide a short and direct response. 1. What is the ratio of the Aid flow (current US$) of Other small states in 1980 to that in 1989?
Keep it short and to the point. 0.17. What is the ratio of the Aid flow (current US$) in Bolivia in 1980 to that in 1989?
Provide a short and direct response. 3.08. What is the ratio of the Aid flow (current US$) of Swaziland in 1980 to that in 1989?
Provide a succinct answer. 2. What is the ratio of the Aid flow (current US$) of Togo in 1980 to that in 1989?
Ensure brevity in your answer.  1. What is the ratio of the Aid flow (current US$) in Other small states in 1980 to that in 1990?
Offer a terse response. 0.07. What is the ratio of the Aid flow (current US$) of Bolivia in 1980 to that in 1990?
Your answer should be very brief. 3.08. What is the ratio of the Aid flow (current US$) in Togo in 1980 to that in 1990?
Offer a terse response. 0.12. What is the ratio of the Aid flow (current US$) of Other small states in 1983 to that in 1986?
Offer a terse response. 0.68. What is the ratio of the Aid flow (current US$) in Bolivia in 1983 to that in 1986?
Your response must be concise. 2.25. What is the ratio of the Aid flow (current US$) of Swaziland in 1983 to that in 1986?
Your answer should be compact. 0.5. What is the ratio of the Aid flow (current US$) of Togo in 1983 to that in 1986?
Offer a terse response. 1. What is the ratio of the Aid flow (current US$) of Other small states in 1983 to that in 1989?
Give a very brief answer. 0.39. What is the ratio of the Aid flow (current US$) of Bolivia in 1983 to that in 1989?
Give a very brief answer. 1.38. What is the ratio of the Aid flow (current US$) of Swaziland in 1983 to that in 1989?
Provide a short and direct response. 1. What is the ratio of the Aid flow (current US$) of Other small states in 1983 to that in 1990?
Your response must be concise. 0.17. What is the ratio of the Aid flow (current US$) in Bolivia in 1983 to that in 1990?
Provide a succinct answer. 1.38. What is the ratio of the Aid flow (current US$) of Togo in 1983 to that in 1990?
Offer a very short reply. 0.12. What is the ratio of the Aid flow (current US$) in Other small states in 1986 to that in 1989?
Give a very brief answer. 0.57. What is the ratio of the Aid flow (current US$) of Bolivia in 1986 to that in 1989?
Ensure brevity in your answer.  0.62. What is the ratio of the Aid flow (current US$) of Swaziland in 1986 to that in 1989?
Your response must be concise. 2. What is the ratio of the Aid flow (current US$) of Other small states in 1986 to that in 1990?
Make the answer very short. 0.26. What is the ratio of the Aid flow (current US$) of Bolivia in 1986 to that in 1990?
Ensure brevity in your answer.  0.62. What is the ratio of the Aid flow (current US$) in Swaziland in 1986 to that in 1990?
Your answer should be compact. 2. What is the ratio of the Aid flow (current US$) in Other small states in 1989 to that in 1990?
Keep it short and to the point. 0.45. What is the ratio of the Aid flow (current US$) of Swaziland in 1989 to that in 1990?
Your answer should be very brief. 1. What is the ratio of the Aid flow (current US$) of Togo in 1989 to that in 1990?
Give a very brief answer. 0.12. What is the difference between the highest and the second highest Aid flow (current US$) in Other small states?
Offer a very short reply. 4.50e+06. What is the difference between the highest and the second highest Aid flow (current US$) of Bolivia?
Your answer should be compact. 8.20e+05. What is the difference between the highest and the second highest Aid flow (current US$) of Togo?
Your response must be concise. 8.40e+05. What is the difference between the highest and the lowest Aid flow (current US$) in Other small states?
Your answer should be compact. 8.03e+06. What is the difference between the highest and the lowest Aid flow (current US$) of Bolivia?
Provide a succinct answer. 1.37e+06. What is the difference between the highest and the lowest Aid flow (current US$) in Togo?
Your answer should be very brief. 1.08e+06. 